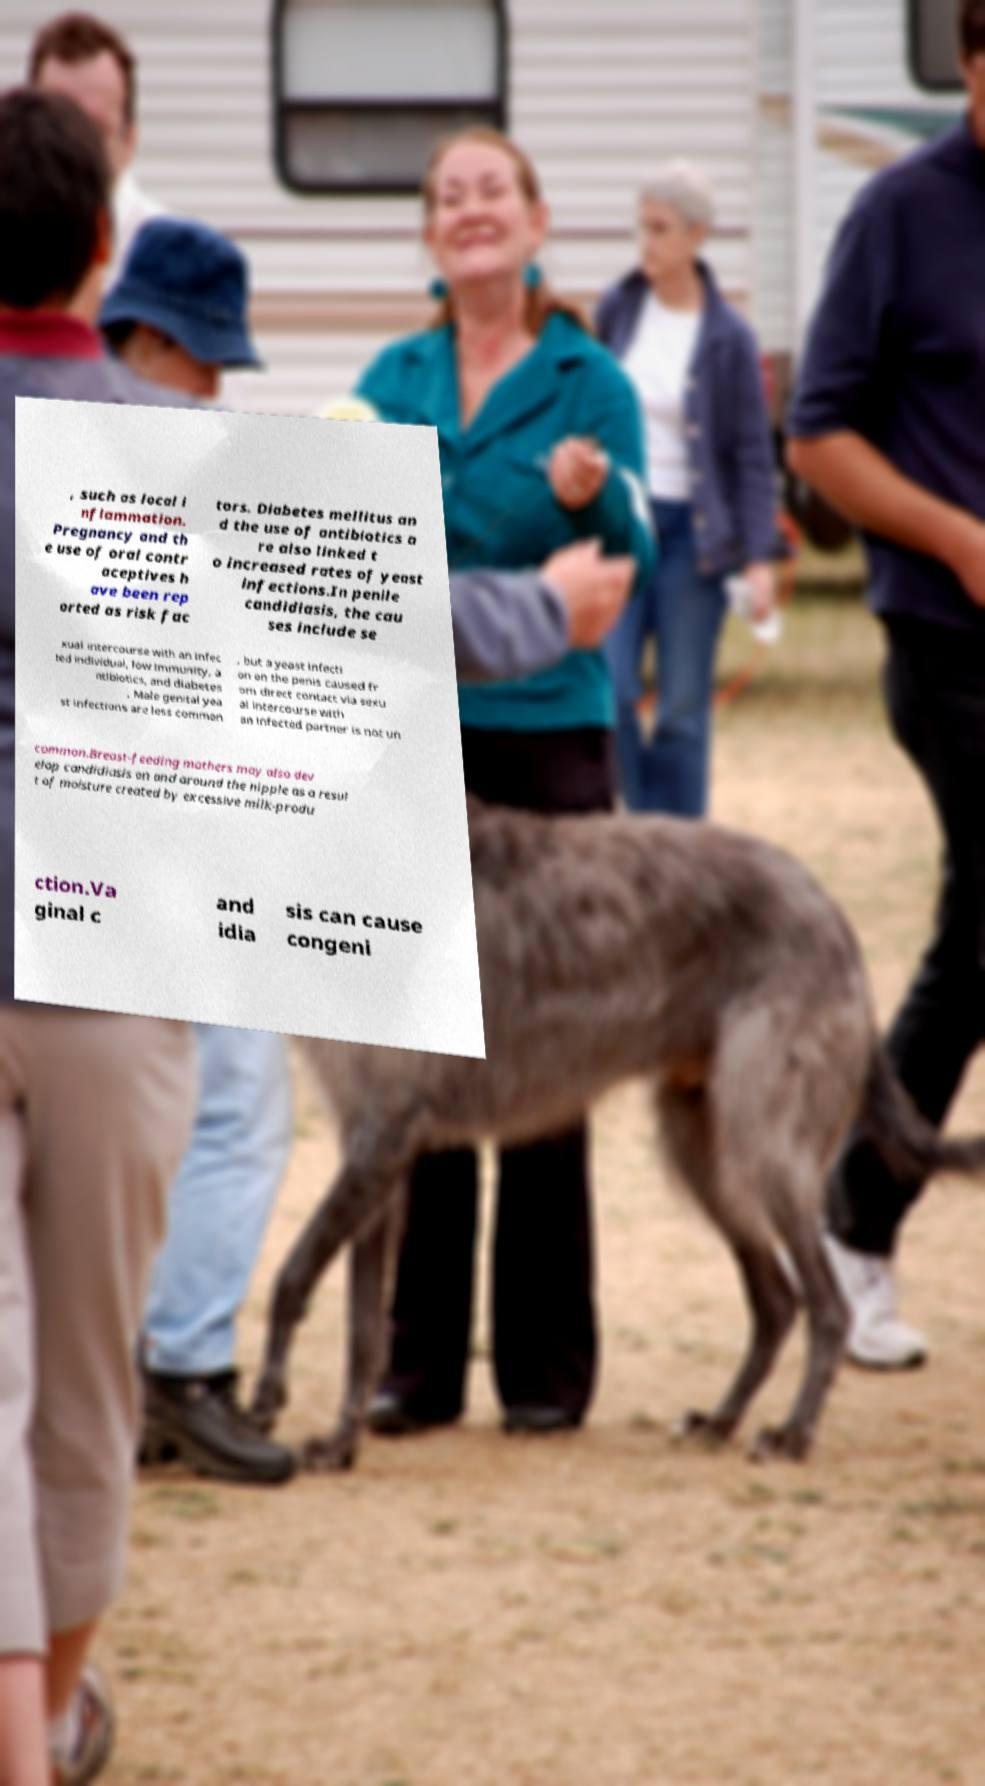Can you accurately transcribe the text from the provided image for me? , such as local i nflammation. Pregnancy and th e use of oral contr aceptives h ave been rep orted as risk fac tors. Diabetes mellitus an d the use of antibiotics a re also linked t o increased rates of yeast infections.In penile candidiasis, the cau ses include se xual intercourse with an infec ted individual, low immunity, a ntibiotics, and diabetes . Male genital yea st infections are less common , but a yeast infecti on on the penis caused fr om direct contact via sexu al intercourse with an infected partner is not un common.Breast-feeding mothers may also dev elop candidiasis on and around the nipple as a resul t of moisture created by excessive milk-produ ction.Va ginal c and idia sis can cause congeni 